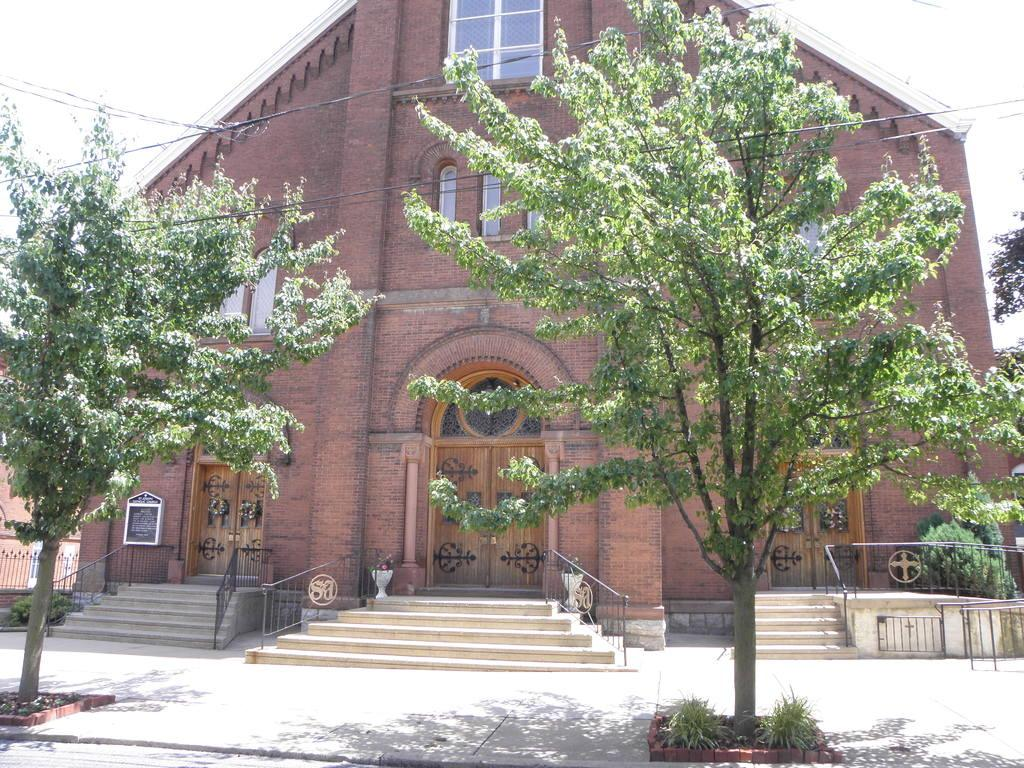What type of natural elements can be seen in the image? There are trees and plants visible in the image. What man-made structures can be seen in the background of the image? There are buildings, windows, doors, steps, and fences visible in the background of the image. What part of the natural environment is visible in the image? The sky is visible in the background of the image. What type of clock can be seen hanging from the trees in the image? There is no clock present in the image, and no clock is hanging from the trees. 